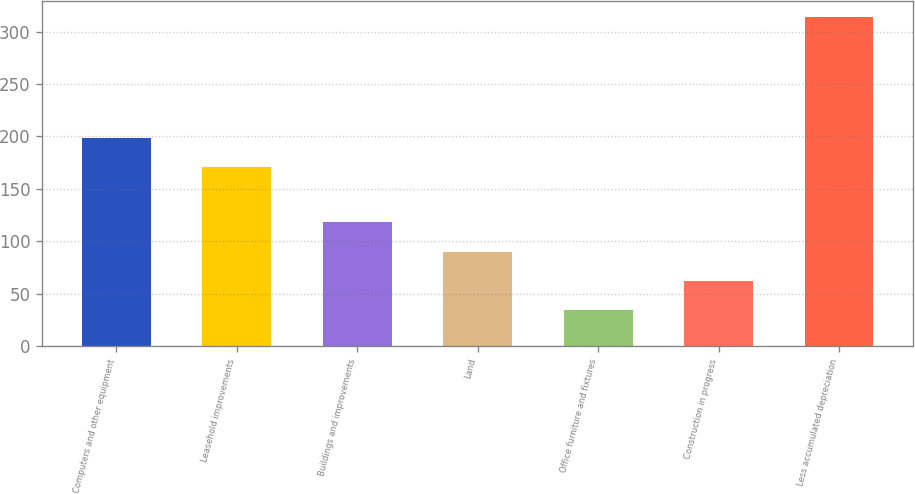<chart> <loc_0><loc_0><loc_500><loc_500><bar_chart><fcel>Computers and other equipment<fcel>Leasehold improvements<fcel>Buildings and improvements<fcel>Land<fcel>Office furniture and fixtures<fcel>Construction in progress<fcel>Less accumulated depreciation<nl><fcel>199<fcel>171<fcel>118<fcel>90<fcel>34<fcel>62<fcel>314<nl></chart> 